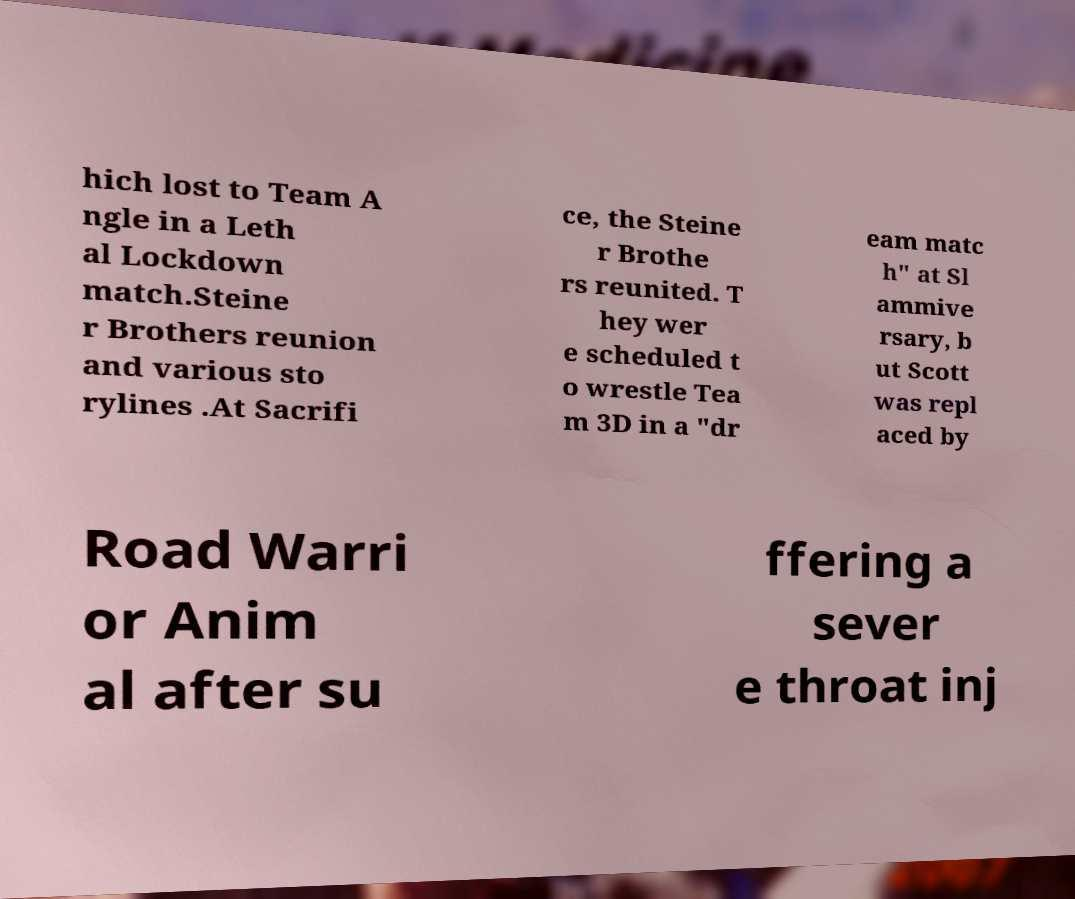Can you read and provide the text displayed in the image?This photo seems to have some interesting text. Can you extract and type it out for me? hich lost to Team A ngle in a Leth al Lockdown match.Steine r Brothers reunion and various sto rylines .At Sacrifi ce, the Steine r Brothe rs reunited. T hey wer e scheduled t o wrestle Tea m 3D in a "dr eam matc h" at Sl ammive rsary, b ut Scott was repl aced by Road Warri or Anim al after su ffering a sever e throat inj 